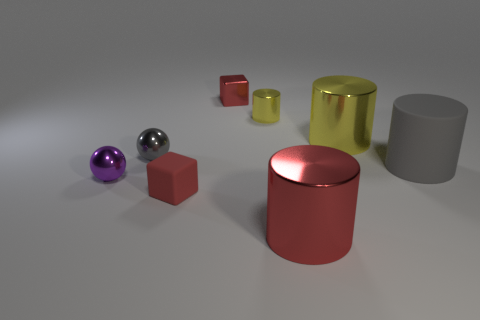Subtract all yellow cylinders. How many were subtracted if there are1yellow cylinders left? 1 Subtract all gray matte cylinders. How many cylinders are left? 3 Add 1 yellow cylinders. How many objects exist? 9 Subtract all yellow spheres. How many yellow cylinders are left? 2 Subtract 2 cylinders. How many cylinders are left? 2 Subtract all gray cylinders. How many cylinders are left? 3 Subtract all cubes. How many objects are left? 6 Subtract all green cylinders. Subtract all brown balls. How many cylinders are left? 4 Subtract all small yellow shiny cylinders. Subtract all big cyan things. How many objects are left? 7 Add 8 yellow cylinders. How many yellow cylinders are left? 10 